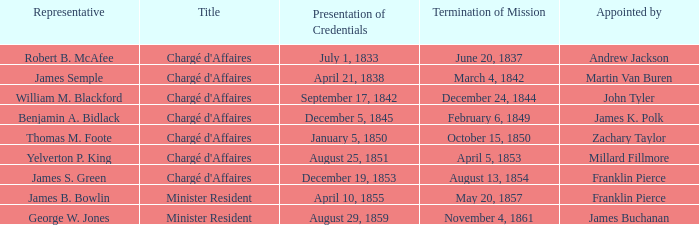Can you provide the title of the mission that was concluded on november 4, 1861? Minister Resident. 